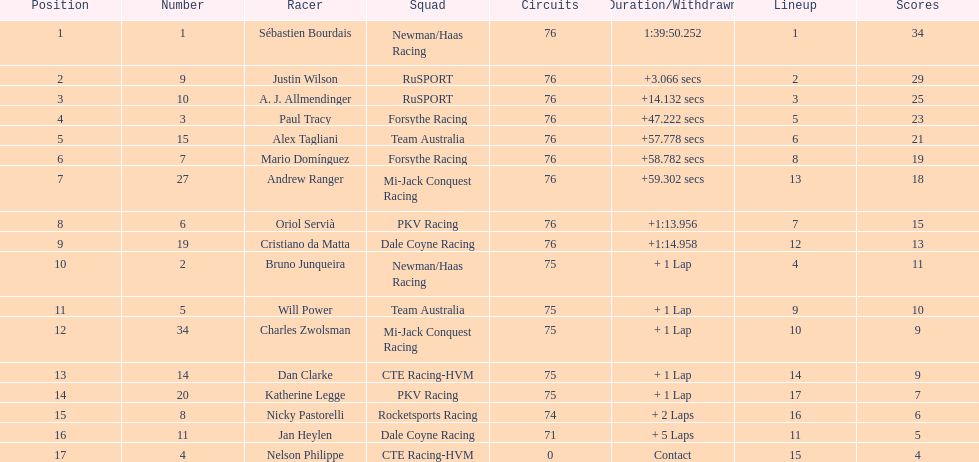Charles zwolsman acquired the same number of points as who? Dan Clarke. 